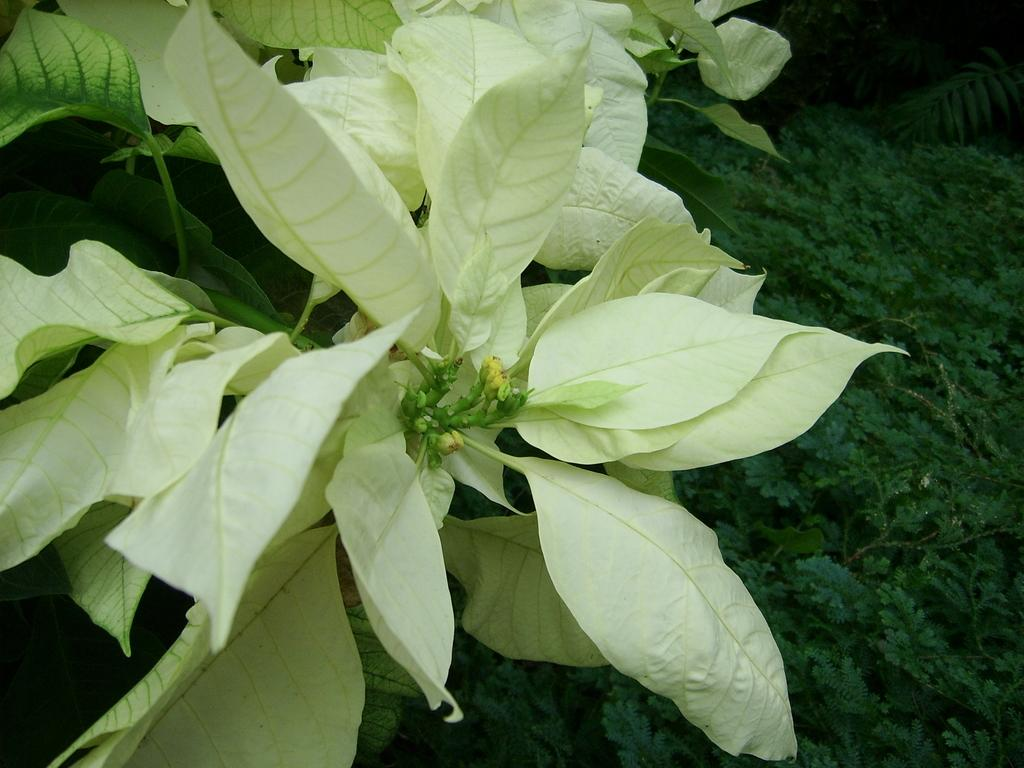What stage of growth are the plants in the image? The plants in the image have buds on their stems, indicating that they are in the early stages of growth. Can you describe the plants in the background of the image? The provided facts do not give specific details about the plants in the background, but we know that they are visible. How many cows are grazing near the plants in the image? There are no cows present in the image; it only features plants. What level of experience is required to care for the plants in the image? The provided facts do not give any information about the level of experience required to care for the plants in the image. 